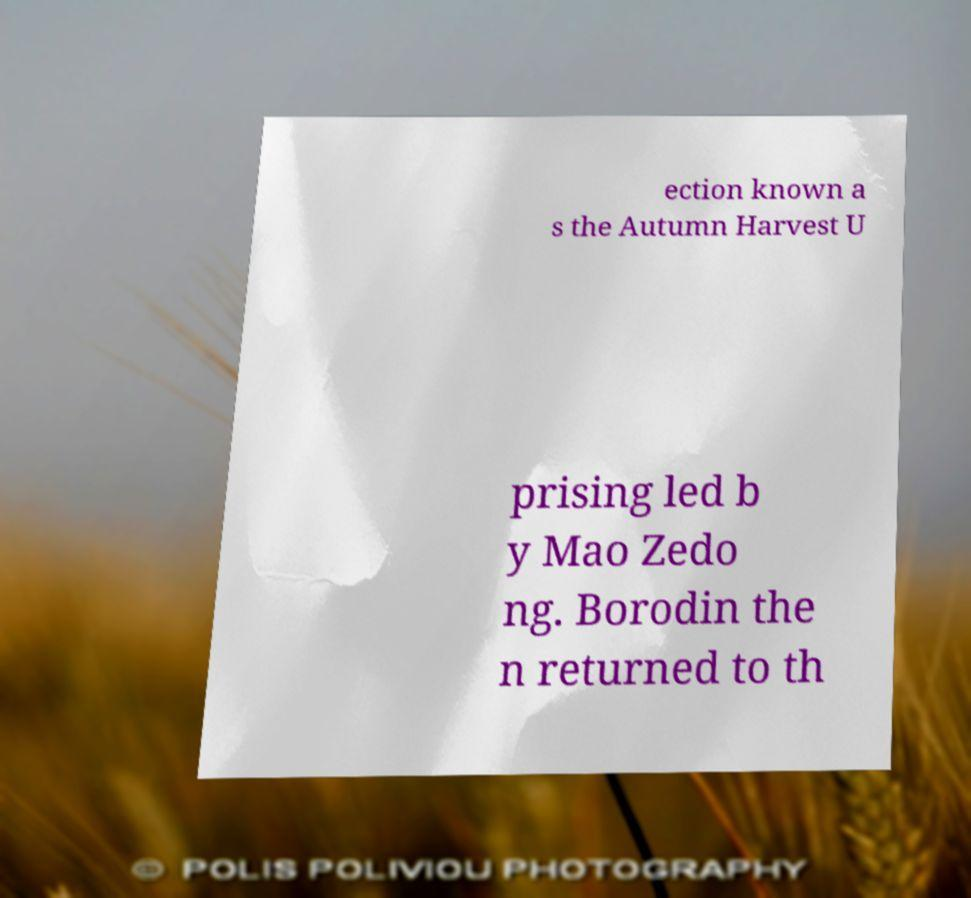Could you extract and type out the text from this image? ection known a s the Autumn Harvest U prising led b y Mao Zedo ng. Borodin the n returned to th 